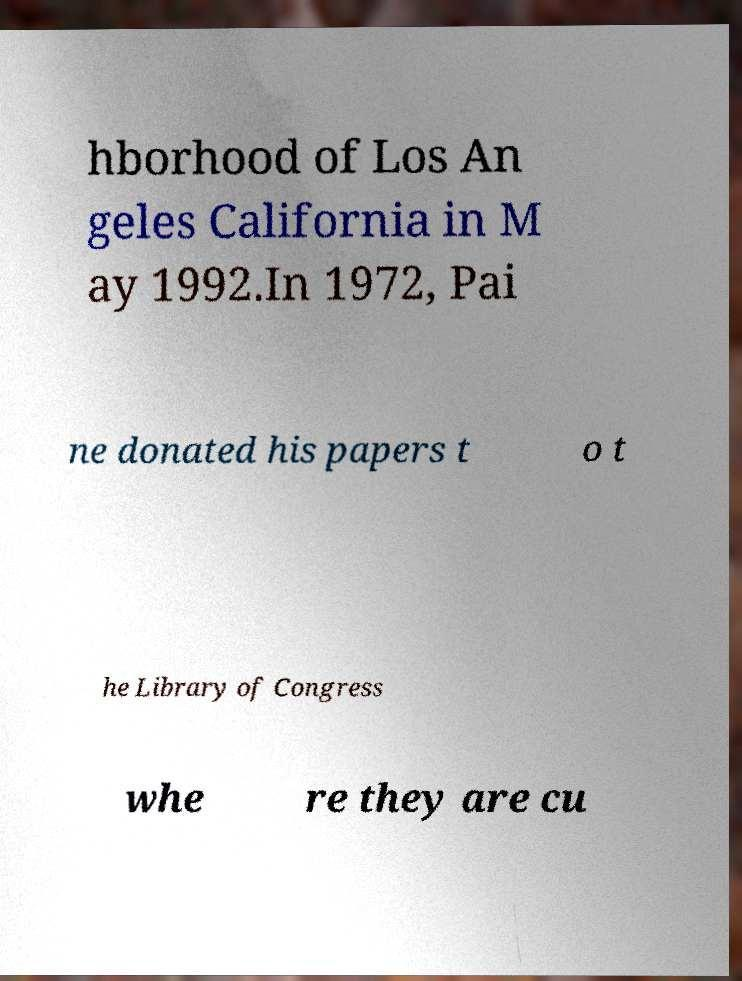For documentation purposes, I need the text within this image transcribed. Could you provide that? hborhood of Los An geles California in M ay 1992.In 1972, Pai ne donated his papers t o t he Library of Congress whe re they are cu 